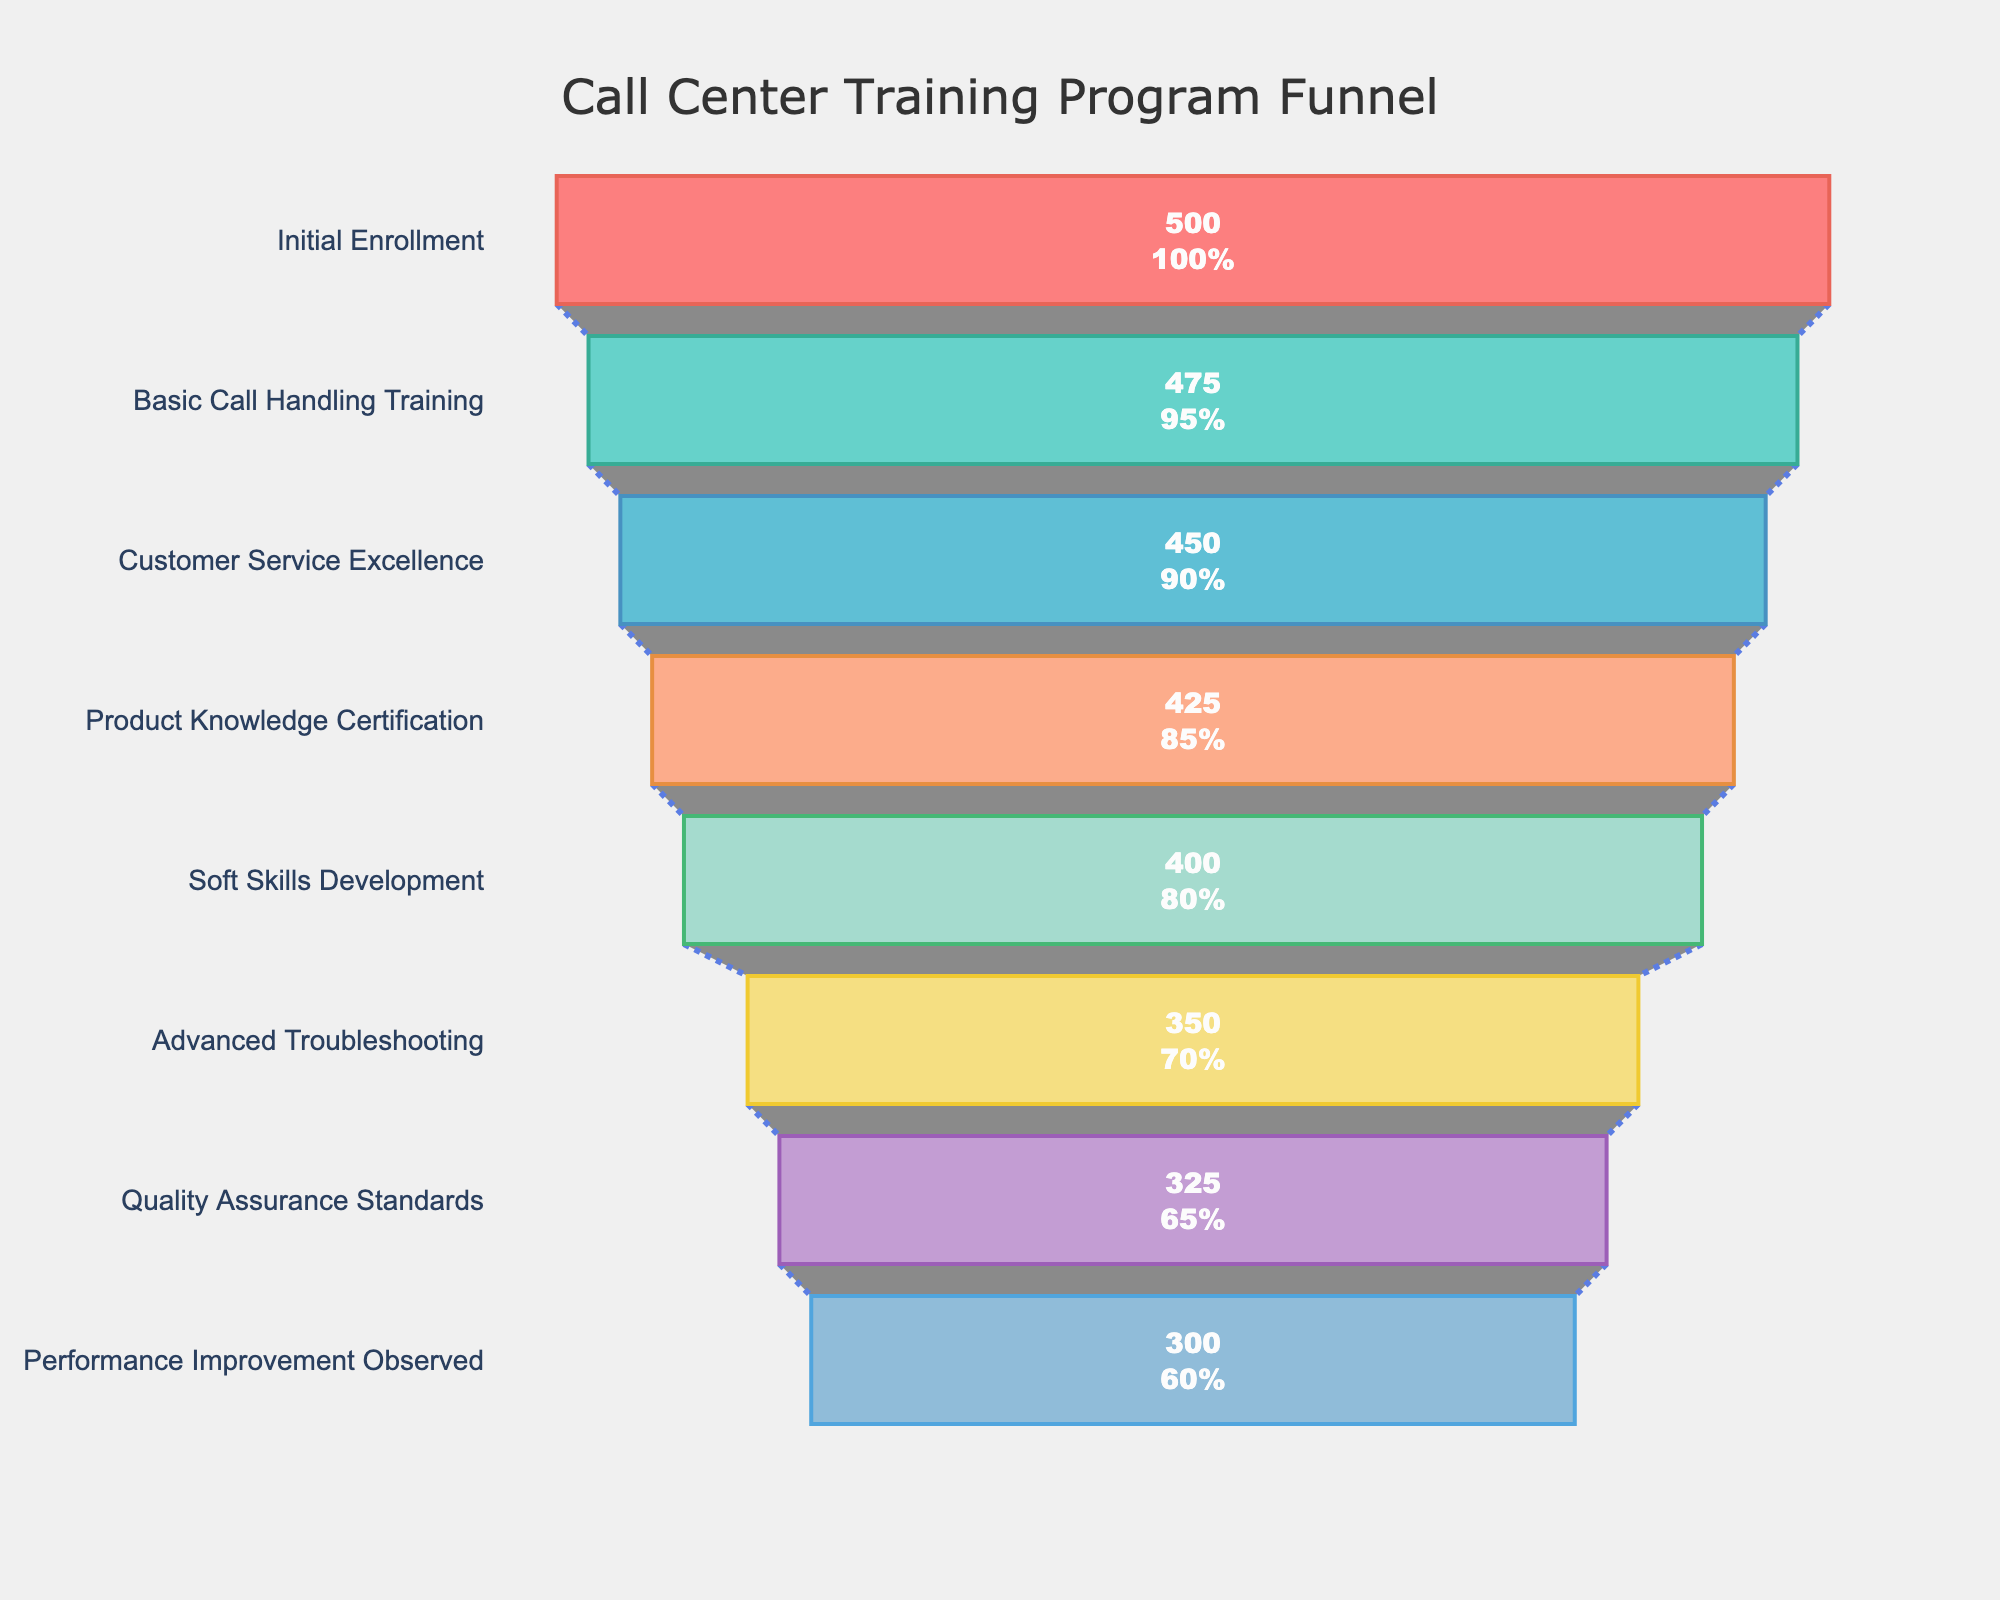What is the title of the funnel chart? The chart's title is prominently displayed at the top, and it reads "Call Center Training Program Funnel".
Answer: Call Center Training Program Funnel How many stages are there in the funnel chart? Counting each level from the top to the bottom, we can see there are a total of 8 stages.
Answer: 8 How many participants completed the Basic Call Handling Training stage? The figure shows the number of participants for each stage. For Basic Call Handling Training, it is 475.
Answer: 475 By what percentage did the participation drop from the Initial Enrollment to the Performance Improvement Observed stage? Initial Enrollment starts with 500 participants, and Performance Improvement Observed ends with 300 participants. The drop percentage is calculated as: ((500 - 300) / 500) * 100% = 40%.
Answer: 40% Which stage had the highest number of participants? The stage with the highest number of participants is "Initial Enrollment" at the top of the funnel with 500 participants.
Answer: Initial Enrollment From the Product Knowledge Certification to the Soft Skills Development stages, how many participants were lost? At the Product Knowledge Certification stage, there are 425 participants, and at the Soft Skills Development stage, there are 400 participants. The difference is 425 - 400 = 25 participants.
Answer: 25 What percentage of participants completed the Customer Service Excellence stage compared to the original enrollees? The figure shows that 450 participants completed the Customer Service Excellence stage. The percentage is (450 / 500) * 100% = 90%.
Answer: 90% Which stage observed the largest drop in participants? Looking at the differences between consecutive stages, the largest drop is between Advanced Troubleshooting (350) and Quality Assurance Standards (325), with a drop of 25 participants.
Answer: Advanced Troubleshooting to Quality Assurance Standards Are there any stages where the participation rate didn't drop by at least 10% compared to the previous stage? Examining each successive stage drop as a percentage of the previous stage: Basic Call Handling Training (95%), Customer Service Excellence (90%), Product Knowledge Certification (85%), Soft Skills Development (80%), Advanced Troubleshooting (70%), Quality Assurance Standards (65%), and Performance Improvement Observed (60%), we see that all stages experience less than a 10% drop from another except from Advanced Troubleshooting to Quality Assurance Standards (350 to 325, which is 7.14%).
Answer: No 